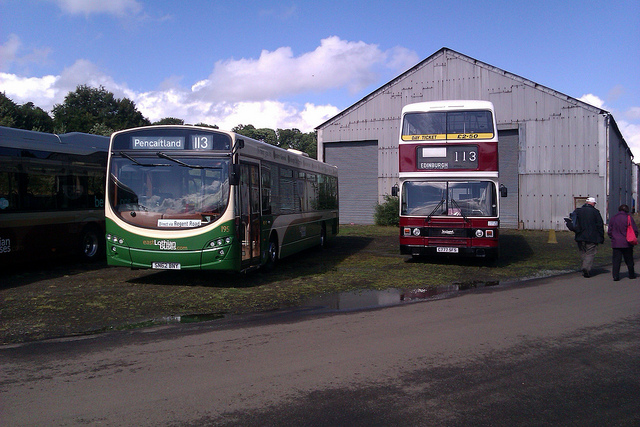Read and extract the text from this image. II3 Pencaitland 1 I 3 